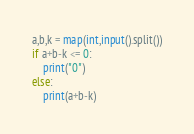Convert code to text. <code><loc_0><loc_0><loc_500><loc_500><_Python_>a,b,k = map(int,input().split())
if a+b-k <= 0:
	print("0")
else:
	print(a+b-k)</code> 